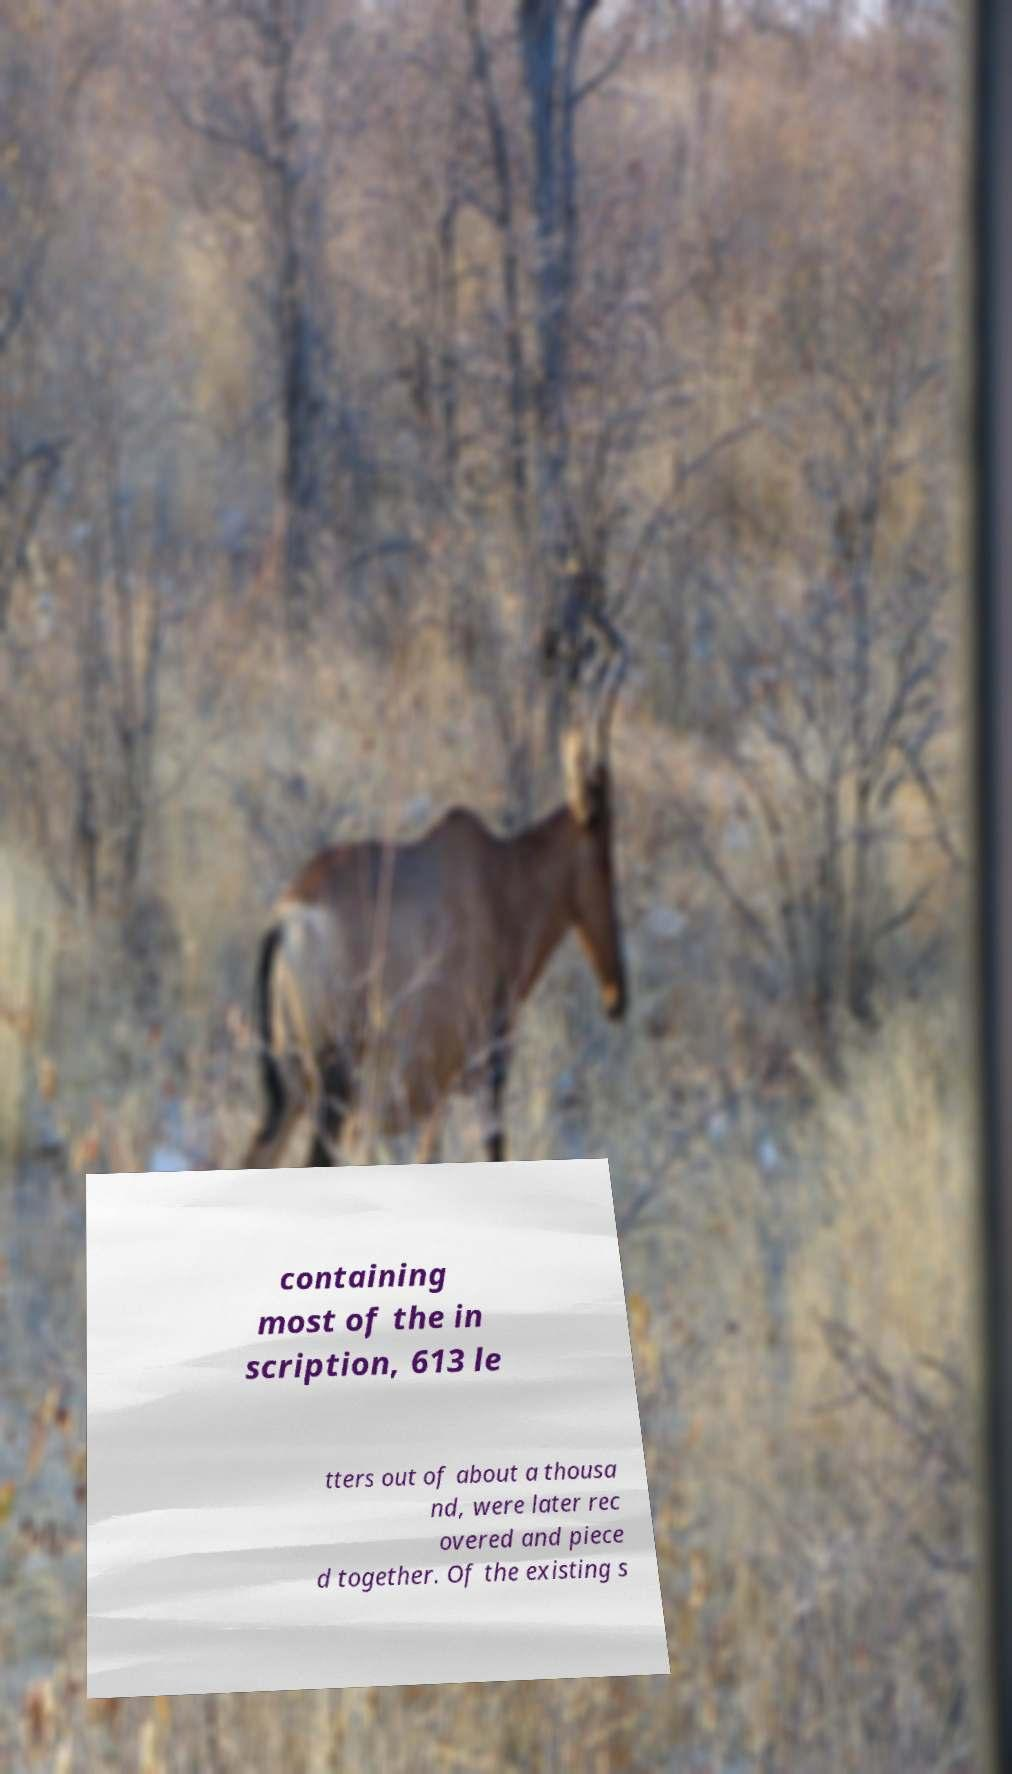Can you read and provide the text displayed in the image?This photo seems to have some interesting text. Can you extract and type it out for me? containing most of the in scription, 613 le tters out of about a thousa nd, were later rec overed and piece d together. Of the existing s 